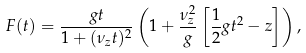Convert formula to latex. <formula><loc_0><loc_0><loc_500><loc_500>F ( t ) = \frac { g t } { 1 + ( \nu _ { z } t ) ^ { 2 } } \left ( 1 + \frac { \nu _ { z } ^ { 2 } } { g } \left [ \frac { 1 } { 2 } g t ^ { 2 } - z \right ] \right ) ,</formula> 